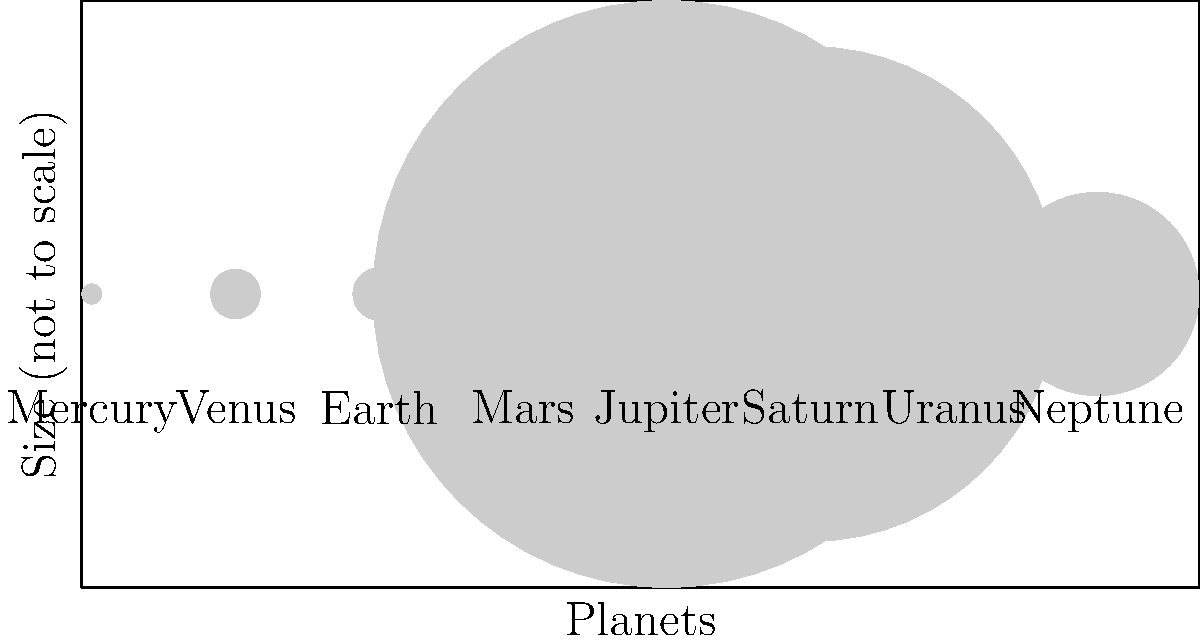In the context of international patent law for space exploration technologies, consider the relative sizes of planets in our solar system. If we were to scale down Jupiter's diameter to 100 units, approximately how many of these units would represent Earth's diameter? To solve this problem, we need to follow these steps:

1. Identify the diameters of Jupiter and Earth from the given data:
   Jupiter's diameter = 142,984 km
   Earth's diameter = 12,756 km

2. Set up a proportion to scale Jupiter's diameter to 100 units:
   $\frac{142,984}{100} = \frac{12,756}{x}$

3. Cross multiply:
   $142,984x = 1,275,600$

4. Solve for x:
   $x = \frac{1,275,600}{142,984} \approx 8.92$

5. Round to the nearest whole number:
   8.92 rounds to 9

This calculation shows that if Jupiter's diameter were scaled to 100 units, Earth's diameter would be approximately 9 units.

In the context of international patent law for space exploration technologies, understanding the relative sizes of planets is crucial for designing and patenting spacecraft and instruments that can operate effectively in different planetary environments.
Answer: 9 units 